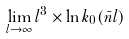<formula> <loc_0><loc_0><loc_500><loc_500>\lim _ { l \rightarrow \infty } l ^ { 3 } \times \ln k _ { 0 } ( \bar { n } l )</formula> 